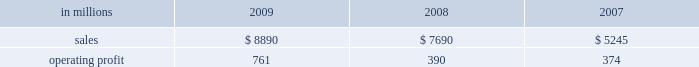Distribution xpedx , our north american merchant distribution business , distributes products and services to a number of customer markets including : commercial printers with printing papers and graphic pre-press , printing presses and post-press equipment ; building services and away-from-home markets with facility supplies ; manufacturers with packaging supplies and equipment ; and to a growing number of customers , we exclusively provide distribution capabilities including warehousing and delivery services .
Xpedx is the leading wholesale distribution marketer in these customer and product segments in north america , operating 122 warehouse locations and 130 retail stores in the united states , mexico and cana- forest products international paper owns and manages approx- imately 200000 acres of forestlands and develop- ment properties in the united states , mostly in the south .
Our remaining forestlands are managed as a portfolio to optimize the economic value to our shareholders .
Most of our portfolio represents prop- erties that are likely to be sold to investors and other buyers for various purposes .
Specialty businesses and other chemicals : this business was sold in the first quarter of 2007 .
Ilim holding s.a .
In october 2007 , international paper and ilim holding s.a .
( ilim ) completed a 50:50 joint venture to operate a pulp and paper business located in russia .
Ilim 2019s facilities include three paper mills located in bratsk , ust-ilimsk , and koryazhma , russia , with combined total pulp and paper capacity of over 2.5 million tons .
Ilim has exclusive harvesting rights on timberland and forest areas exceeding 12.8 million acres ( 5.2 million hectares ) .
Products and brand designations appearing in italics are trademarks of international paper or a related company .
Industry segment results industrial packaging demand for industrial packaging products is closely correlated with non-durable industrial goods pro- duction , as well as with demand for processed foods , poultry , meat and agricultural products .
In addition to prices and volumes , major factors affecting the profitability of industrial packaging are raw material and energy costs , freight costs , manufacturing effi- ciency and product mix .
Industrial packaging results for 2009 and 2008 include the cbpr business acquired in the 2008 third quarter .
Net sales for 2009 increased 16% ( 16 % ) to $ 8.9 billion compared with $ 7.7 billion in 2008 , and 69% ( 69 % ) compared with $ 5.2 billion in 2007 .
Operating profits were 95% ( 95 % ) higher in 2009 than in 2008 and more than double 2007 levels .
Benefits from higher total year-over-year shipments , including the impact of the cbpr business , ( $ 11 million ) , favorable operating costs ( $ 294 million ) , and lower raw material and freight costs ( $ 295 million ) were parti- ally offset by the effects of lower price realizations ( $ 243 million ) , higher corporate overhead allocations ( $ 85 million ) , incremental integration costs asso- ciated with the acquisition of the cbpr business ( $ 3 million ) and higher other costs ( $ 7 million ) .
Additionally , operating profits in 2009 included a gain of $ 849 million relating to alternative fuel mix- ture credits , u.s .
Plant closure costs of $ 653 million , and costs associated with the shutdown of the eti- enne mill in france of $ 87 million .
Industrial packaging in millions 2009 2008 2007 .
North american industrial packaging results include the net sales and operating profits of the cbpr business from the august 4 , 2008 acquis- ition date .
Net sales were $ 7.6 billion in 2009 com- pared with $ 6.2 billion in 2008 and $ 3.9 billion in 2007 .
Operating profits in 2009 were $ 791 million ( $ 682 million excluding alternative fuel mixture cred- its , mill closure costs and costs associated with the cbpr integration ) compared with $ 322 million ( $ 414 million excluding charges related to the write-up of cbpr inventory to fair value , cbpr integration costs and other facility closure costs ) in 2008 and $ 305 million in 2007 .
Excluding the effect of the cbpr acquisition , con- tainerboard and box shipments were lower in 2009 compared with 2008 reflecting weaker customer demand .
Average sales price realizations were sig- nificantly lower for both containerboard and boxes due to weaker world-wide economic conditions .
However , average sales margins for boxes .
What was the increase in industrial packaging sales between 2007 and 2008? 
Computations: (7690 - 5245)
Answer: 2445.0. Distribution xpedx , our north american merchant distribution business , distributes products and services to a number of customer markets including : commercial printers with printing papers and graphic pre-press , printing presses and post-press equipment ; building services and away-from-home markets with facility supplies ; manufacturers with packaging supplies and equipment ; and to a growing number of customers , we exclusively provide distribution capabilities including warehousing and delivery services .
Xpedx is the leading wholesale distribution marketer in these customer and product segments in north america , operating 122 warehouse locations and 130 retail stores in the united states , mexico and cana- forest products international paper owns and manages approx- imately 200000 acres of forestlands and develop- ment properties in the united states , mostly in the south .
Our remaining forestlands are managed as a portfolio to optimize the economic value to our shareholders .
Most of our portfolio represents prop- erties that are likely to be sold to investors and other buyers for various purposes .
Specialty businesses and other chemicals : this business was sold in the first quarter of 2007 .
Ilim holding s.a .
In october 2007 , international paper and ilim holding s.a .
( ilim ) completed a 50:50 joint venture to operate a pulp and paper business located in russia .
Ilim 2019s facilities include three paper mills located in bratsk , ust-ilimsk , and koryazhma , russia , with combined total pulp and paper capacity of over 2.5 million tons .
Ilim has exclusive harvesting rights on timberland and forest areas exceeding 12.8 million acres ( 5.2 million hectares ) .
Products and brand designations appearing in italics are trademarks of international paper or a related company .
Industry segment results industrial packaging demand for industrial packaging products is closely correlated with non-durable industrial goods pro- duction , as well as with demand for processed foods , poultry , meat and agricultural products .
In addition to prices and volumes , major factors affecting the profitability of industrial packaging are raw material and energy costs , freight costs , manufacturing effi- ciency and product mix .
Industrial packaging results for 2009 and 2008 include the cbpr business acquired in the 2008 third quarter .
Net sales for 2009 increased 16% ( 16 % ) to $ 8.9 billion compared with $ 7.7 billion in 2008 , and 69% ( 69 % ) compared with $ 5.2 billion in 2007 .
Operating profits were 95% ( 95 % ) higher in 2009 than in 2008 and more than double 2007 levels .
Benefits from higher total year-over-year shipments , including the impact of the cbpr business , ( $ 11 million ) , favorable operating costs ( $ 294 million ) , and lower raw material and freight costs ( $ 295 million ) were parti- ally offset by the effects of lower price realizations ( $ 243 million ) , higher corporate overhead allocations ( $ 85 million ) , incremental integration costs asso- ciated with the acquisition of the cbpr business ( $ 3 million ) and higher other costs ( $ 7 million ) .
Additionally , operating profits in 2009 included a gain of $ 849 million relating to alternative fuel mix- ture credits , u.s .
Plant closure costs of $ 653 million , and costs associated with the shutdown of the eti- enne mill in france of $ 87 million .
Industrial packaging in millions 2009 2008 2007 .
North american industrial packaging results include the net sales and operating profits of the cbpr business from the august 4 , 2008 acquis- ition date .
Net sales were $ 7.6 billion in 2009 com- pared with $ 6.2 billion in 2008 and $ 3.9 billion in 2007 .
Operating profits in 2009 were $ 791 million ( $ 682 million excluding alternative fuel mixture cred- its , mill closure costs and costs associated with the cbpr integration ) compared with $ 322 million ( $ 414 million excluding charges related to the write-up of cbpr inventory to fair value , cbpr integration costs and other facility closure costs ) in 2008 and $ 305 million in 2007 .
Excluding the effect of the cbpr acquisition , con- tainerboard and box shipments were lower in 2009 compared with 2008 reflecting weaker customer demand .
Average sales price realizations were sig- nificantly lower for both containerboard and boxes due to weaker world-wide economic conditions .
However , average sales margins for boxes .
What was the increase in industrial packaging sales between 2008 and 2009? 
Computations: (8890 - 7690)
Answer: 1200.0. 